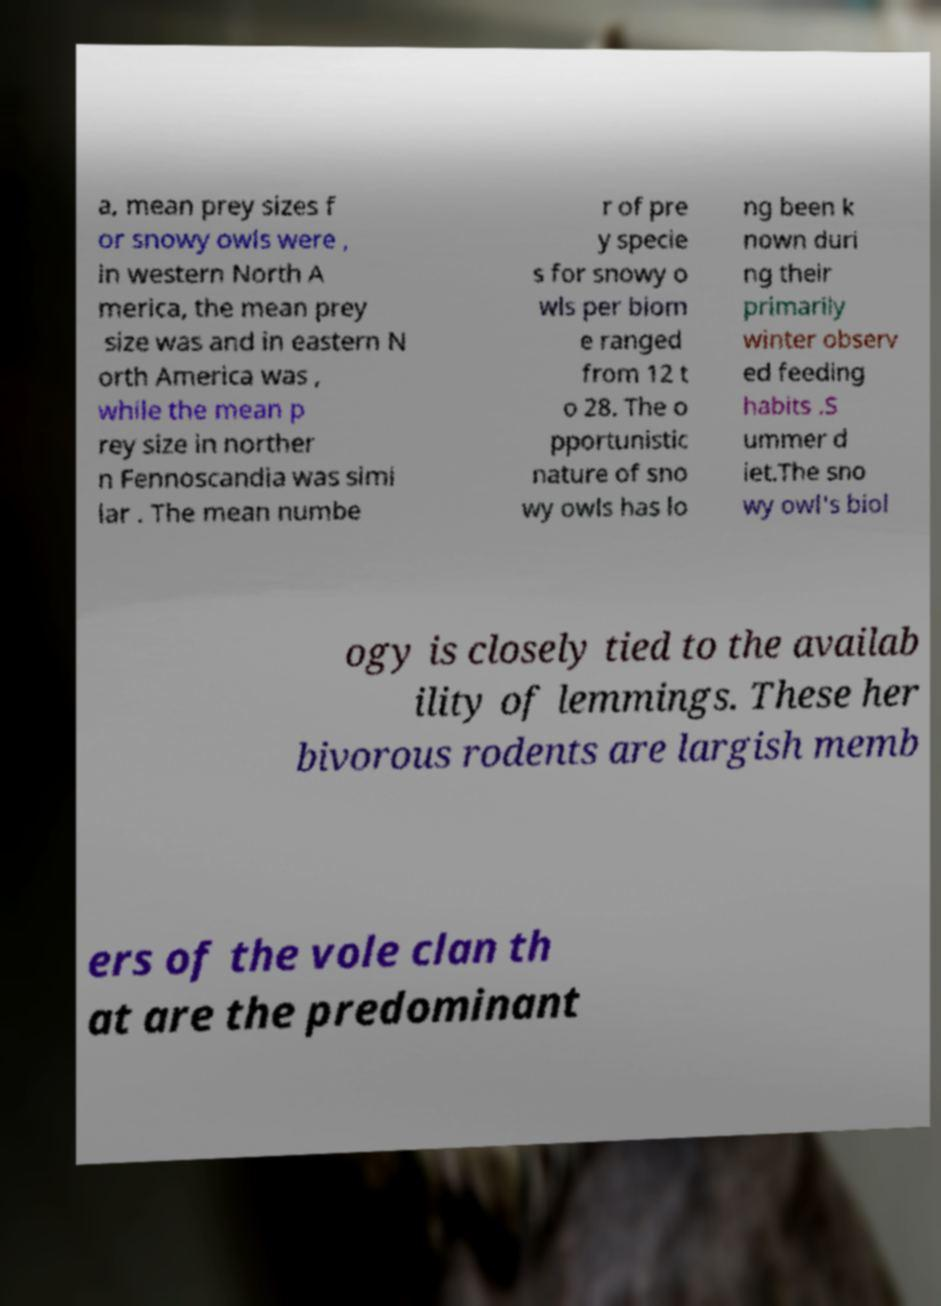For documentation purposes, I need the text within this image transcribed. Could you provide that? a, mean prey sizes f or snowy owls were , in western North A merica, the mean prey size was and in eastern N orth America was , while the mean p rey size in norther n Fennoscandia was simi lar . The mean numbe r of pre y specie s for snowy o wls per biom e ranged from 12 t o 28. The o pportunistic nature of sno wy owls has lo ng been k nown duri ng their primarily winter observ ed feeding habits .S ummer d iet.The sno wy owl's biol ogy is closely tied to the availab ility of lemmings. These her bivorous rodents are largish memb ers of the vole clan th at are the predominant 